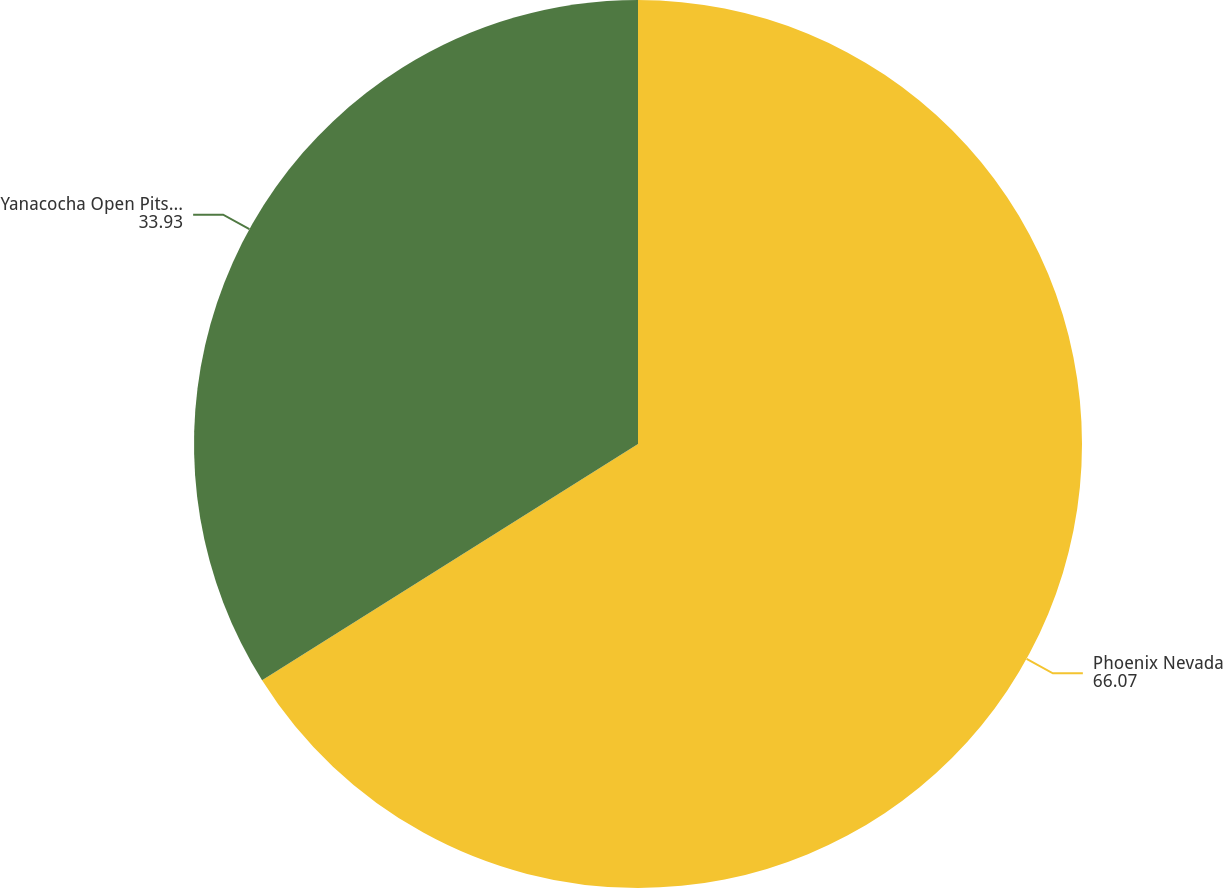Convert chart to OTSL. <chart><loc_0><loc_0><loc_500><loc_500><pie_chart><fcel>Phoenix Nevada<fcel>Yanacocha Open Pits and<nl><fcel>66.07%<fcel>33.93%<nl></chart> 